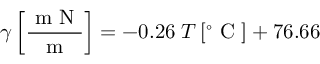Convert formula to latex. <formula><loc_0><loc_0><loc_500><loc_500>\gamma \left [ \frac { m N } { m } \right ] = - 0 . 2 6 \, T \, [ ^ { \circ } C ] + 7 6 . 6 6</formula> 